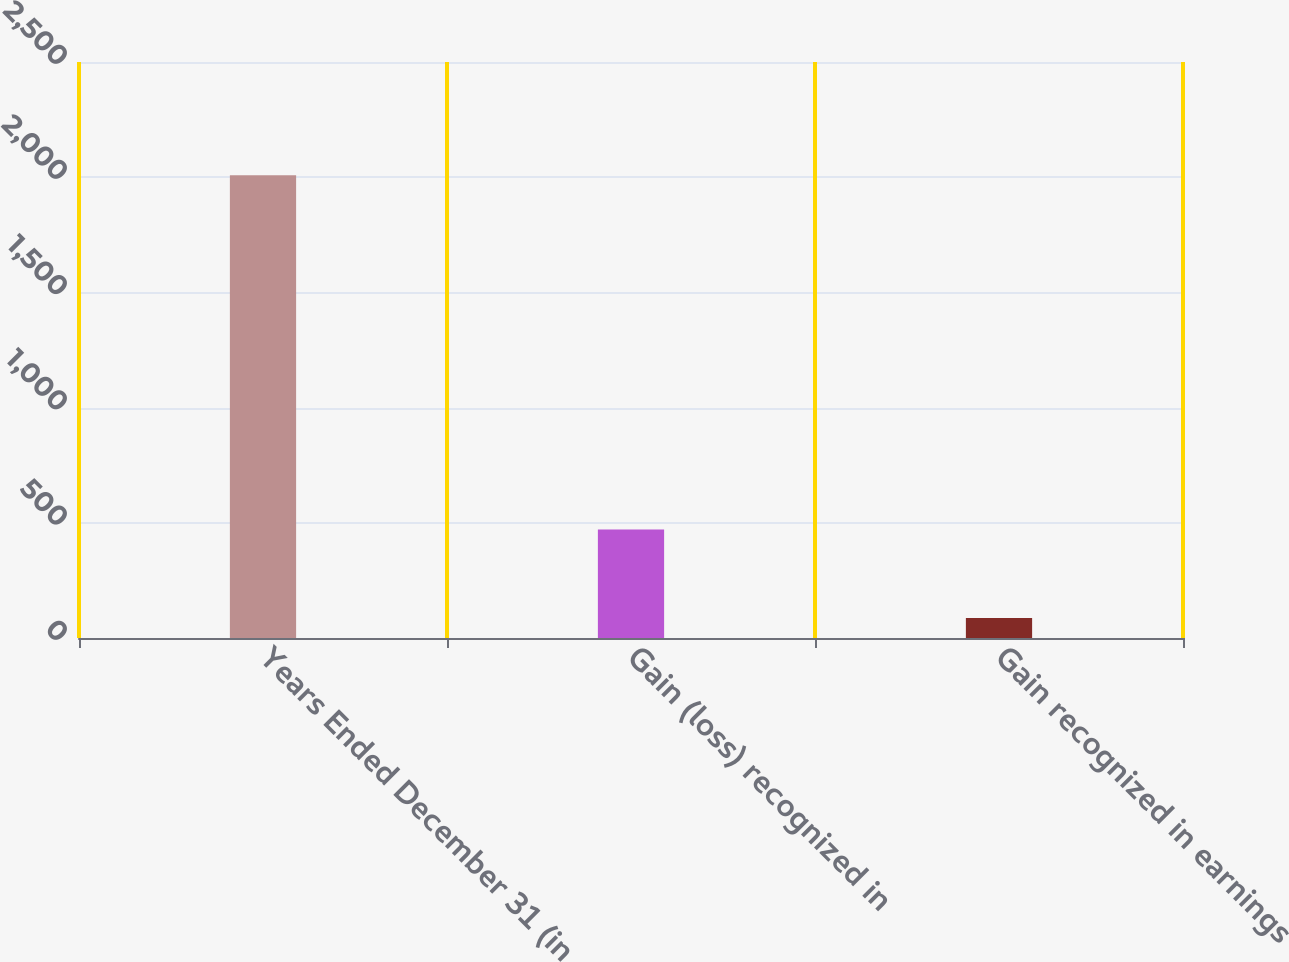Convert chart to OTSL. <chart><loc_0><loc_0><loc_500><loc_500><bar_chart><fcel>Years Ended December 31 (in<fcel>Gain (loss) recognized in<fcel>Gain recognized in earnings<nl><fcel>2009<fcel>471.4<fcel>87<nl></chart> 